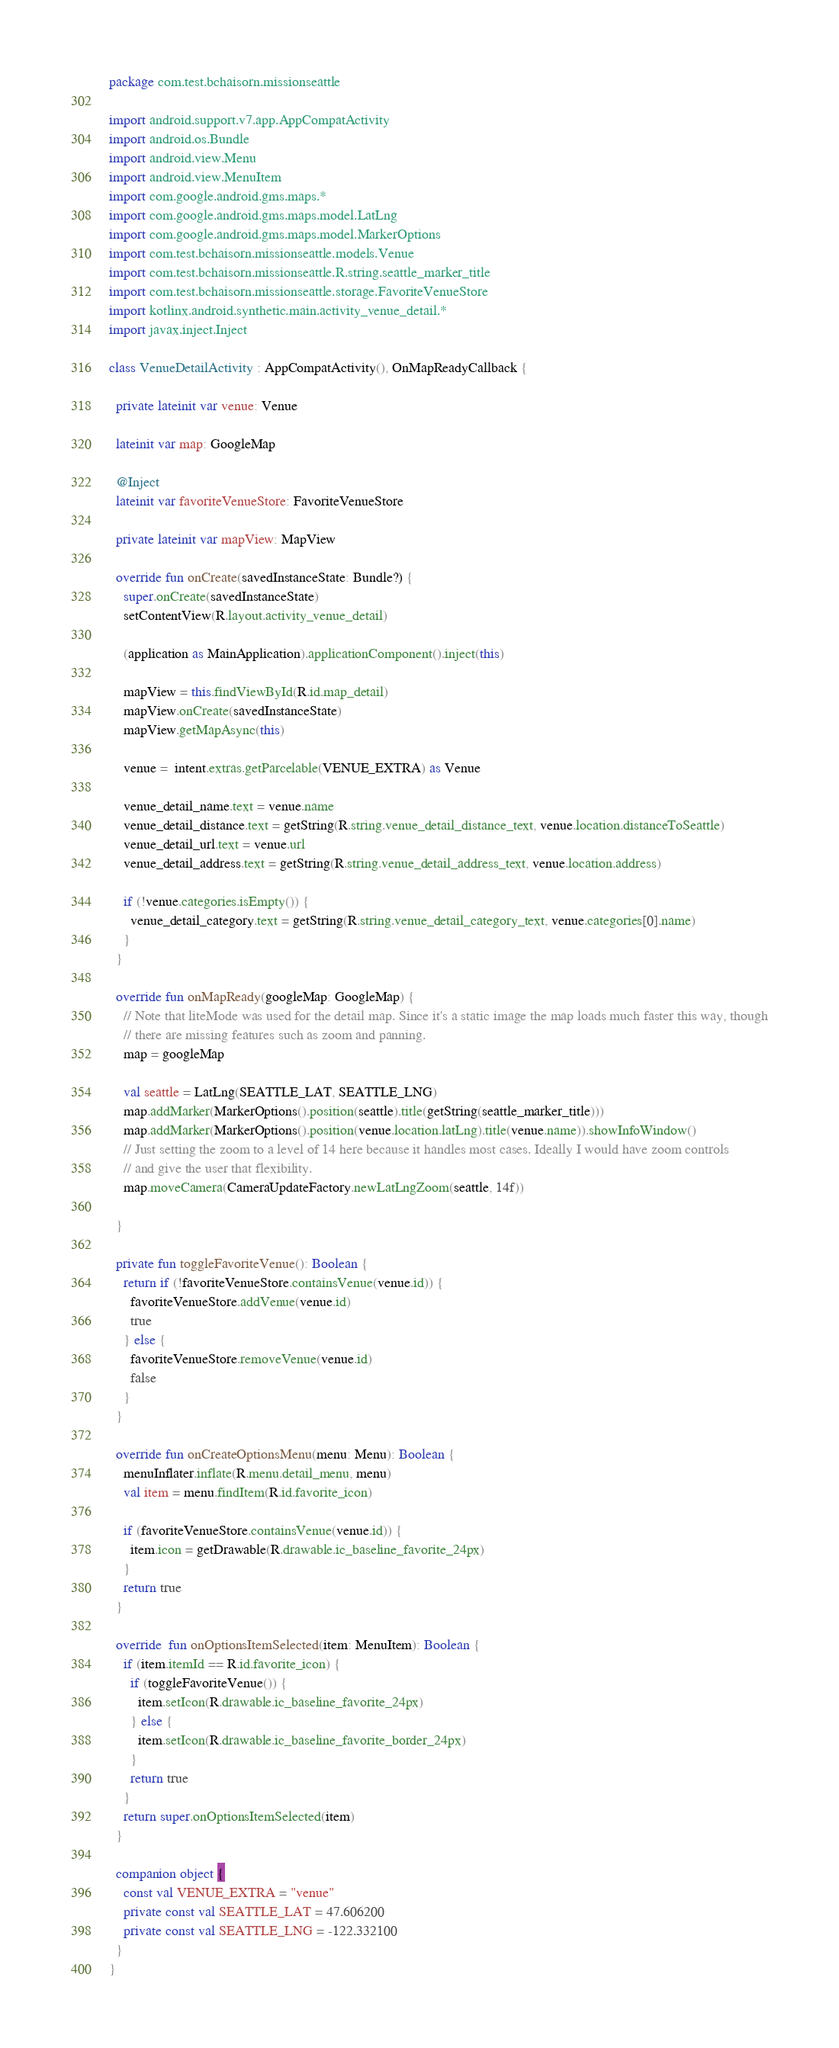Convert code to text. <code><loc_0><loc_0><loc_500><loc_500><_Kotlin_>package com.test.bchaisorn.missionseattle

import android.support.v7.app.AppCompatActivity
import android.os.Bundle
import android.view.Menu
import android.view.MenuItem
import com.google.android.gms.maps.*
import com.google.android.gms.maps.model.LatLng
import com.google.android.gms.maps.model.MarkerOptions
import com.test.bchaisorn.missionseattle.models.Venue
import com.test.bchaisorn.missionseattle.R.string.seattle_marker_title
import com.test.bchaisorn.missionseattle.storage.FavoriteVenueStore
import kotlinx.android.synthetic.main.activity_venue_detail.*
import javax.inject.Inject

class VenueDetailActivity : AppCompatActivity(), OnMapReadyCallback {

  private lateinit var venue: Venue

  lateinit var map: GoogleMap

  @Inject
  lateinit var favoriteVenueStore: FavoriteVenueStore

  private lateinit var mapView: MapView

  override fun onCreate(savedInstanceState: Bundle?) {
    super.onCreate(savedInstanceState)
    setContentView(R.layout.activity_venue_detail)

    (application as MainApplication).applicationComponent().inject(this)

    mapView = this.findViewById(R.id.map_detail)
    mapView.onCreate(savedInstanceState)
    mapView.getMapAsync(this)

    venue =  intent.extras.getParcelable(VENUE_EXTRA) as Venue

    venue_detail_name.text = venue.name
    venue_detail_distance.text = getString(R.string.venue_detail_distance_text, venue.location.distanceToSeattle)
    venue_detail_url.text = venue.url
    venue_detail_address.text = getString(R.string.venue_detail_address_text, venue.location.address)

    if (!venue.categories.isEmpty()) {
      venue_detail_category.text = getString(R.string.venue_detail_category_text, venue.categories[0].name)
    }
  }

  override fun onMapReady(googleMap: GoogleMap) {
    // Note that liteMode was used for the detail map. Since it's a static image the map loads much faster this way, though
    // there are missing features such as zoom and panning.
    map = googleMap

    val seattle = LatLng(SEATTLE_LAT, SEATTLE_LNG)
    map.addMarker(MarkerOptions().position(seattle).title(getString(seattle_marker_title)))
    map.addMarker(MarkerOptions().position(venue.location.latLng).title(venue.name)).showInfoWindow()
    // Just setting the zoom to a level of 14 here because it handles most cases. Ideally I would have zoom controls
    // and give the user that flexibility.
    map.moveCamera(CameraUpdateFactory.newLatLngZoom(seattle, 14f))

  }

  private fun toggleFavoriteVenue(): Boolean {
    return if (!favoriteVenueStore.containsVenue(venue.id)) {
      favoriteVenueStore.addVenue(venue.id)
      true
    } else {
      favoriteVenueStore.removeVenue(venue.id)
      false
    }
  }

  override fun onCreateOptionsMenu(menu: Menu): Boolean {
    menuInflater.inflate(R.menu.detail_menu, menu)
    val item = menu.findItem(R.id.favorite_icon)

    if (favoriteVenueStore.containsVenue(venue.id)) {
      item.icon = getDrawable(R.drawable.ic_baseline_favorite_24px)
    }
    return true
  }

  override  fun onOptionsItemSelected(item: MenuItem): Boolean {
    if (item.itemId == R.id.favorite_icon) {
      if (toggleFavoriteVenue()) {
        item.setIcon(R.drawable.ic_baseline_favorite_24px)
      } else {
        item.setIcon(R.drawable.ic_baseline_favorite_border_24px)
      }
      return true
    }
    return super.onOptionsItemSelected(item)
  }

  companion object {
    const val VENUE_EXTRA = "venue"
    private const val SEATTLE_LAT = 47.606200
    private const val SEATTLE_LNG = -122.332100
  }
}
</code> 